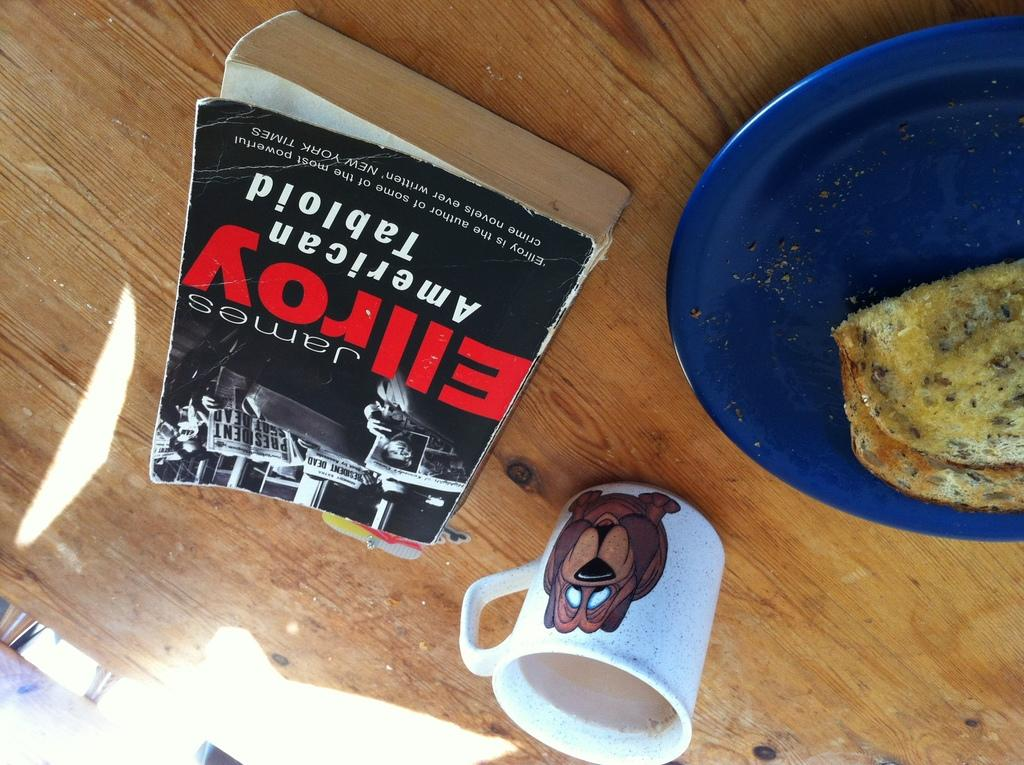Provide a one-sentence caption for the provided image. A tattered James Ellroy paperback is titled American Tabloid. 